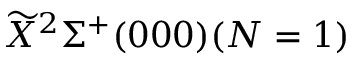Convert formula to latex. <formula><loc_0><loc_0><loc_500><loc_500>\widetilde { X } ^ { 2 } \Sigma ^ { + } ( 0 0 0 ) ( N = 1 )</formula> 